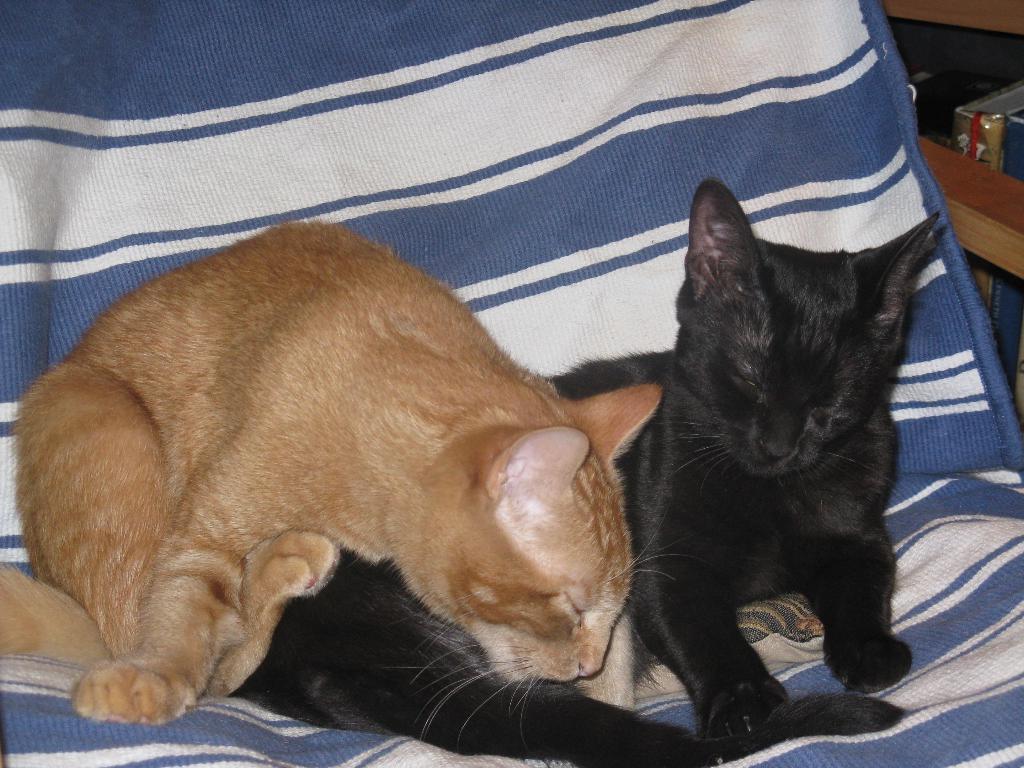Could you give a brief overview of what you see in this image? In the picture I can see a black cat and golden color cat are sitting on the blue and white color surface. Here we can see books are kept in the wooden cupboard which is on the right side of the image. 